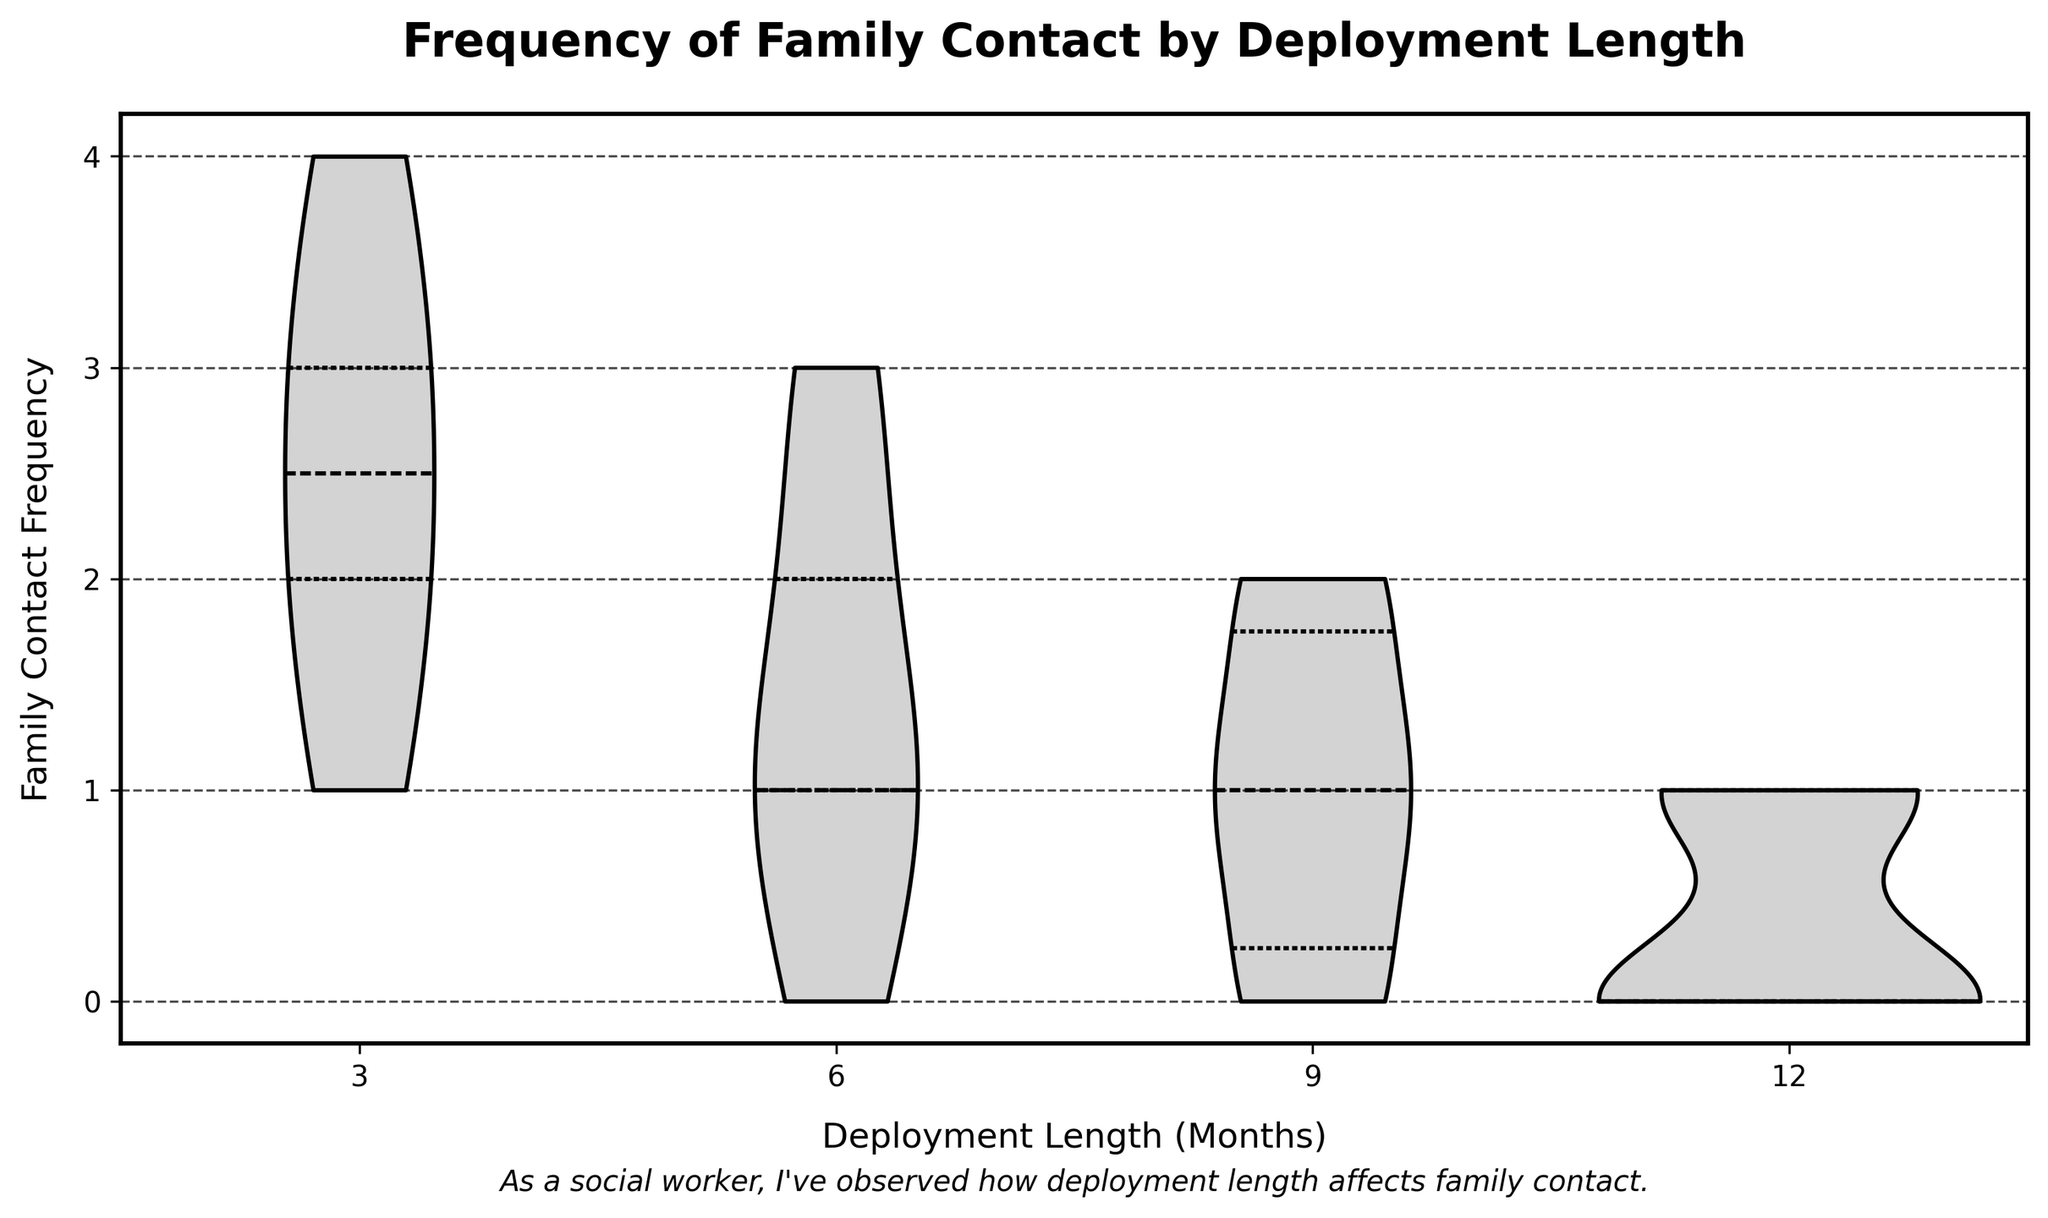How does the title of the figure relate to the data shown? The title "Frequency of Family Contact by Deployment Length" directly relates to the data shown by describing the relationship between sailors' deployment lengths and how often they contact their families, which is depicted on the x-axis and y-axis, respectively.
Answer: The title describes the relationship between deployment length and family contact frequency What is represented on the x-axis of the figure? The x-axis of the figure represents the deployment length in months. It shows different categories of deployment lengths such as 3, 6, 9, and 12 months.
Answer: Deployment Length (Months) What is the range of values on the y-axis? The y-axis represents the family contact frequency, with values ranging from 0 to 4. This illustrates the frequency at which sailors contact their families during their deployment.
Answer: 0 to 4 Which deployment length category has the widest range of family contact frequencies? The deployment length category of 3 months has the widest range, spanning from a frequency of 1 to 4. This is evidenced by the more spread-out distribution in the 3-month violin plot compared to the others.
Answer: 3 months What can you infer about the family contact frequency for sailors deployed for 12 months? For sailors deployed for 12 months, the family contact frequency is predominantly between 0 and 1. This is observed from the dense part of the violin plot near these lower frequencies.
Answer: Predominantly between 0 and 1 How does the median family contact frequency differ between deployment lengths of 6 months and 12 months? The median family contact frequency for a 6-month deployment is higher than that for a 12-month deployment. The violin plot for 6 months shows the center (median) slightly above 1, while for 12 months, it is at 0.
Answer: Higher for 6 months than for 12 months Which deployment length has the most consistent family contact frequency? The deployment length of 12 months has the most consistent family contact frequency, as indicated by the narrowest, tallest violin plot with less variation around the median, mostly concentrated at lower frequencies.
Answer: 12 months Is there a deployment length where the family contact frequency of "3" has a notable representation? Yes, the 3-month deployment length has a notable representation of the family contact frequency of "3". In the violin plot, there is a visible peak at this frequency.
Answer: 3 months Compare the upper quartile family contact frequencies for 6-month and 9-month deployments. The upper quartile (75th percentile) family contact frequency for 6-month deployments is higher than that for 9-month deployments. In the violin plots, this is indicated by the upper edge of the shaded area inside each plot.
Answer: Higher for 6 months than 9 months What does the density shape of the violin plot indicate about family contact frequency for a 9-month deployment? The density shape of the violin plot for a 9-month deployment indicates that while some sailors contact their families frequently, the distribution is heavy around 0 and 1, suggesting a significant portion of sailors have very infrequent contact.
Answer: Heavy around 0 and 1, suggesting infrequent contact for many sailors 